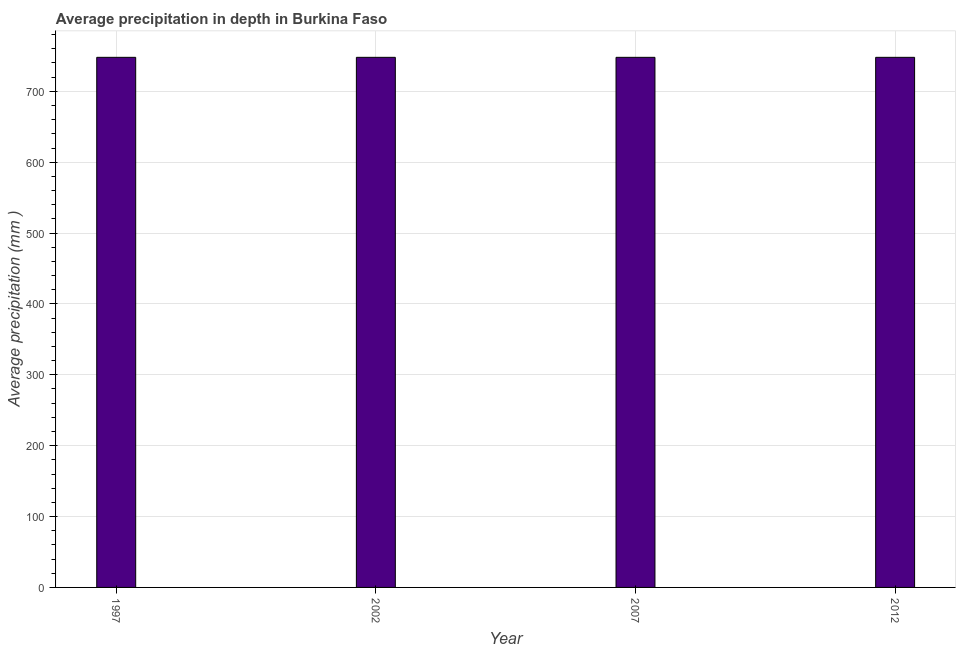Does the graph contain any zero values?
Give a very brief answer. No. Does the graph contain grids?
Your answer should be very brief. Yes. What is the title of the graph?
Your answer should be compact. Average precipitation in depth in Burkina Faso. What is the label or title of the X-axis?
Provide a succinct answer. Year. What is the label or title of the Y-axis?
Your answer should be very brief. Average precipitation (mm ). What is the average precipitation in depth in 2002?
Offer a very short reply. 748. Across all years, what is the maximum average precipitation in depth?
Ensure brevity in your answer.  748. Across all years, what is the minimum average precipitation in depth?
Offer a terse response. 748. In which year was the average precipitation in depth maximum?
Give a very brief answer. 1997. In which year was the average precipitation in depth minimum?
Provide a succinct answer. 1997. What is the sum of the average precipitation in depth?
Give a very brief answer. 2992. What is the average average precipitation in depth per year?
Offer a terse response. 748. What is the median average precipitation in depth?
Keep it short and to the point. 748. In how many years, is the average precipitation in depth greater than 740 mm?
Give a very brief answer. 4. What is the ratio of the average precipitation in depth in 2002 to that in 2012?
Your answer should be compact. 1. Is the average precipitation in depth in 2007 less than that in 2012?
Your answer should be compact. No. In how many years, is the average precipitation in depth greater than the average average precipitation in depth taken over all years?
Your answer should be compact. 0. How many bars are there?
Give a very brief answer. 4. Are all the bars in the graph horizontal?
Your answer should be very brief. No. How many years are there in the graph?
Your answer should be very brief. 4. Are the values on the major ticks of Y-axis written in scientific E-notation?
Your response must be concise. No. What is the Average precipitation (mm ) in 1997?
Your response must be concise. 748. What is the Average precipitation (mm ) of 2002?
Give a very brief answer. 748. What is the Average precipitation (mm ) of 2007?
Offer a terse response. 748. What is the Average precipitation (mm ) in 2012?
Offer a very short reply. 748. What is the difference between the Average precipitation (mm ) in 2002 and 2007?
Offer a very short reply. 0. What is the difference between the Average precipitation (mm ) in 2002 and 2012?
Provide a short and direct response. 0. What is the difference between the Average precipitation (mm ) in 2007 and 2012?
Your answer should be very brief. 0. What is the ratio of the Average precipitation (mm ) in 1997 to that in 2002?
Your response must be concise. 1. What is the ratio of the Average precipitation (mm ) in 2002 to that in 2007?
Your response must be concise. 1. 